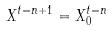Convert formula to latex. <formula><loc_0><loc_0><loc_500><loc_500>X ^ { t = n + 1 } = X _ { 0 } ^ { t = n }</formula> 